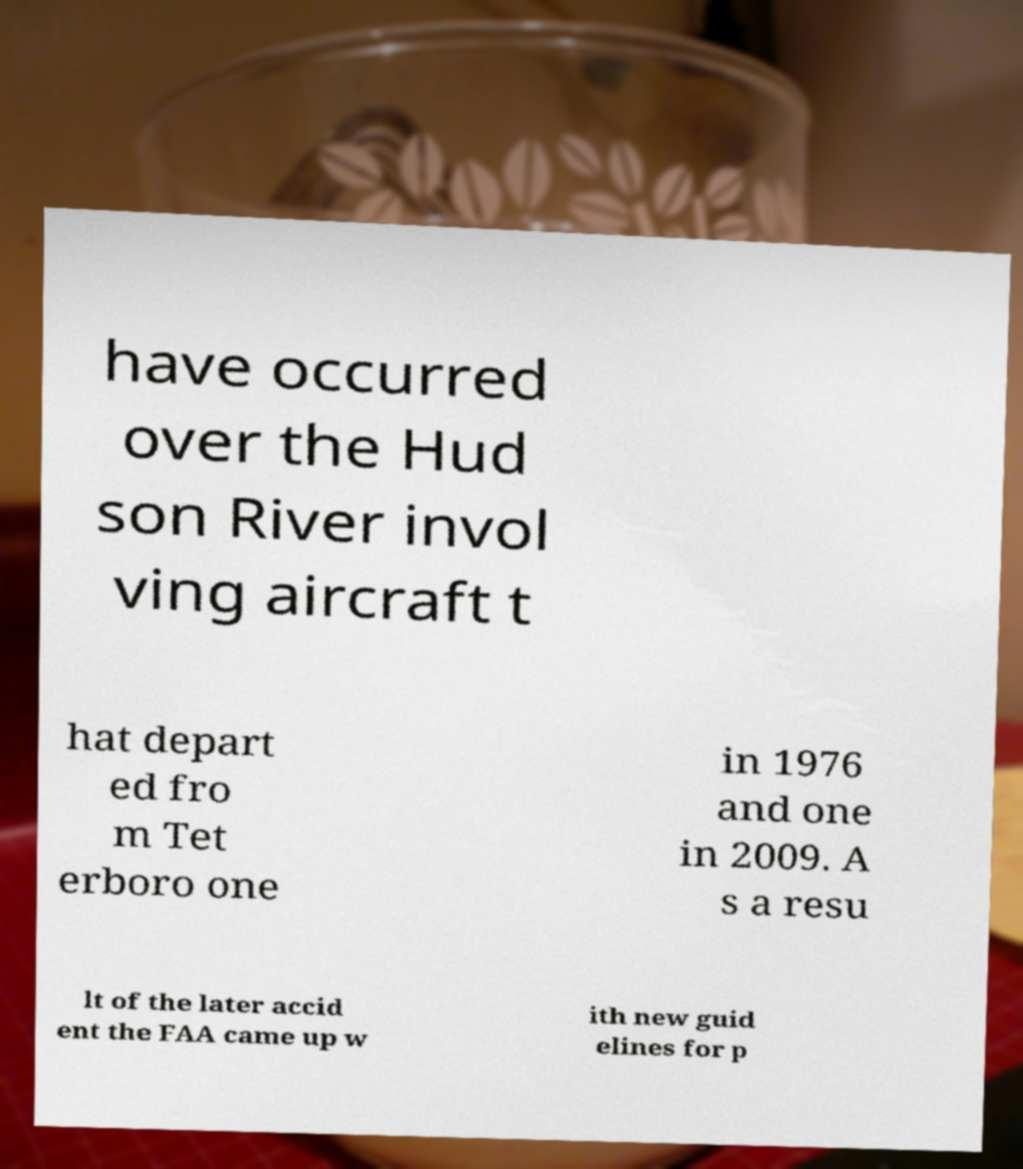There's text embedded in this image that I need extracted. Can you transcribe it verbatim? have occurred over the Hud son River invol ving aircraft t hat depart ed fro m Tet erboro one in 1976 and one in 2009. A s a resu lt of the later accid ent the FAA came up w ith new guid elines for p 